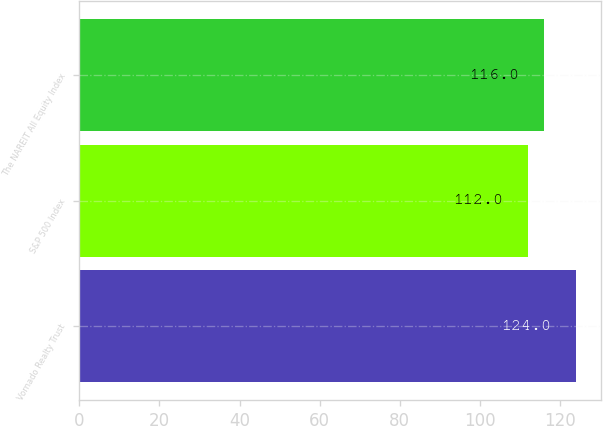Convert chart. <chart><loc_0><loc_0><loc_500><loc_500><bar_chart><fcel>Vornado Realty Trust<fcel>S&P 500 Index<fcel>The NAREIT All Equity Index<nl><fcel>124<fcel>112<fcel>116<nl></chart> 